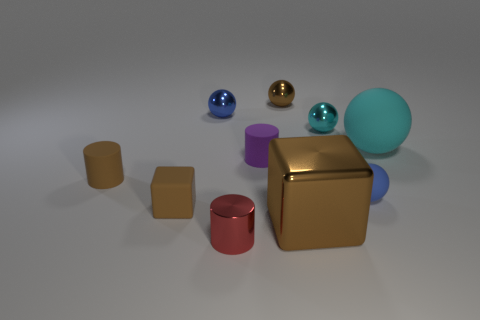What number of things are both to the left of the big cyan rubber object and in front of the tiny blue shiny ball?
Make the answer very short. 7. The brown cube that is made of the same material as the small cyan ball is what size?
Provide a short and direct response. Large. What is the size of the blue rubber ball?
Your answer should be compact. Small. What material is the tiny brown block?
Provide a short and direct response. Rubber. There is a cyan sphere that is to the left of the cyan matte sphere; is its size the same as the big brown shiny block?
Give a very brief answer. No. What number of objects are either brown cylinders or small metallic spheres?
Keep it short and to the point. 4. What shape is the large shiny object that is the same color as the rubber block?
Your response must be concise. Cube. What is the size of the brown object that is in front of the blue metal thing and right of the blue metal thing?
Make the answer very short. Large. How many tiny brown objects are there?
Provide a succinct answer. 3. What number of balls are big green metallic things or small blue things?
Offer a terse response. 2. 